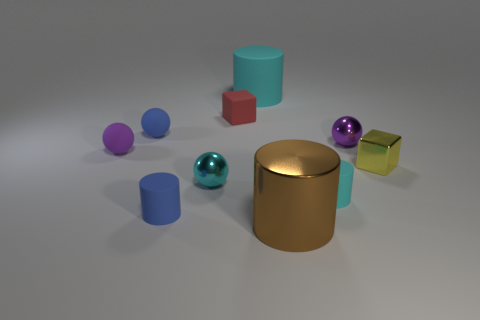Subtract all small blue balls. How many balls are left? 3 Subtract all yellow blocks. How many blocks are left? 1 Subtract all cylinders. How many objects are left? 6 Subtract all purple cylinders. Subtract all purple spheres. How many cylinders are left? 4 Subtract all purple balls. How many purple cylinders are left? 0 Subtract all tiny blocks. Subtract all rubber cylinders. How many objects are left? 5 Add 7 small purple objects. How many small purple objects are left? 9 Add 1 brown balls. How many brown balls exist? 1 Subtract 0 purple cylinders. How many objects are left? 10 Subtract 1 spheres. How many spheres are left? 3 